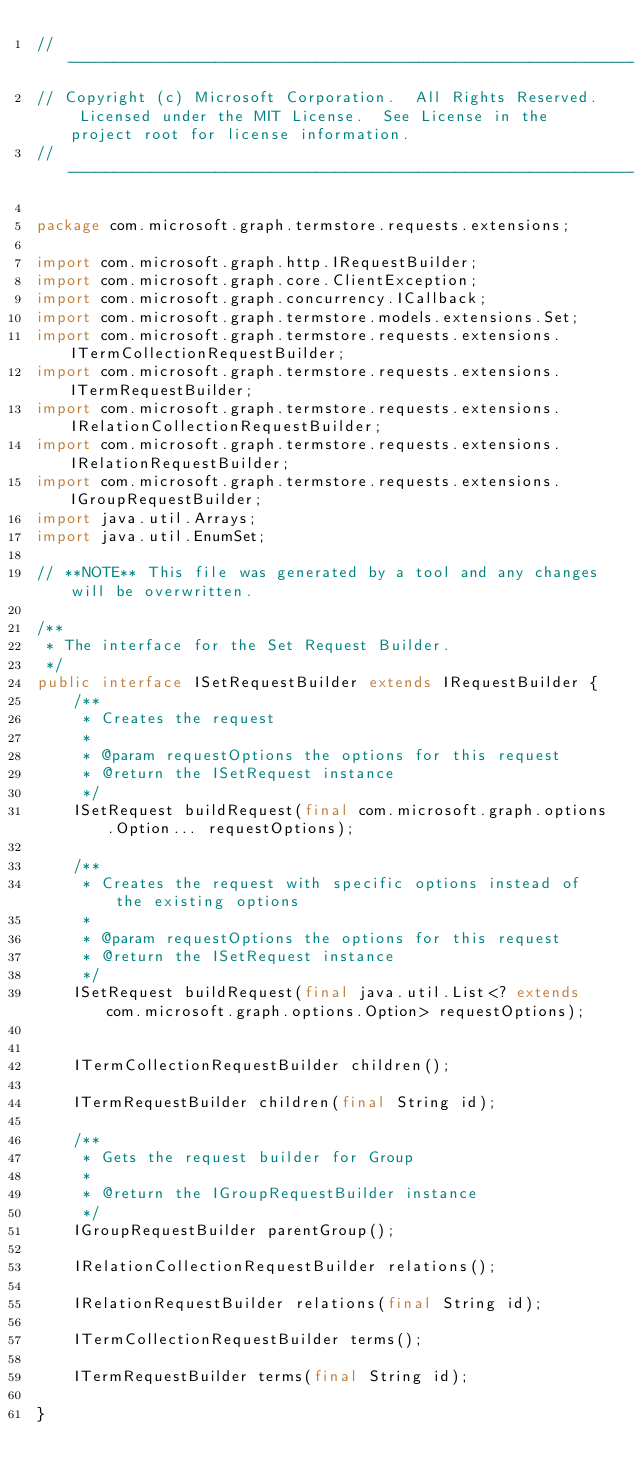Convert code to text. <code><loc_0><loc_0><loc_500><loc_500><_Java_>// ------------------------------------------------------------------------------
// Copyright (c) Microsoft Corporation.  All Rights Reserved.  Licensed under the MIT License.  See License in the project root for license information.
// ------------------------------------------------------------------------------

package com.microsoft.graph.termstore.requests.extensions;

import com.microsoft.graph.http.IRequestBuilder;
import com.microsoft.graph.core.ClientException;
import com.microsoft.graph.concurrency.ICallback;
import com.microsoft.graph.termstore.models.extensions.Set;
import com.microsoft.graph.termstore.requests.extensions.ITermCollectionRequestBuilder;
import com.microsoft.graph.termstore.requests.extensions.ITermRequestBuilder;
import com.microsoft.graph.termstore.requests.extensions.IRelationCollectionRequestBuilder;
import com.microsoft.graph.termstore.requests.extensions.IRelationRequestBuilder;
import com.microsoft.graph.termstore.requests.extensions.IGroupRequestBuilder;
import java.util.Arrays;
import java.util.EnumSet;

// **NOTE** This file was generated by a tool and any changes will be overwritten.

/**
 * The interface for the Set Request Builder.
 */
public interface ISetRequestBuilder extends IRequestBuilder {
    /**
     * Creates the request
     *
     * @param requestOptions the options for this request
     * @return the ISetRequest instance
     */
    ISetRequest buildRequest(final com.microsoft.graph.options.Option... requestOptions);

    /**
     * Creates the request with specific options instead of the existing options
     *
     * @param requestOptions the options for this request
     * @return the ISetRequest instance
     */
    ISetRequest buildRequest(final java.util.List<? extends com.microsoft.graph.options.Option> requestOptions);


    ITermCollectionRequestBuilder children();

    ITermRequestBuilder children(final String id);

    /**
     * Gets the request builder for Group
     *
     * @return the IGroupRequestBuilder instance
     */
    IGroupRequestBuilder parentGroup();

    IRelationCollectionRequestBuilder relations();

    IRelationRequestBuilder relations(final String id);

    ITermCollectionRequestBuilder terms();

    ITermRequestBuilder terms(final String id);

}</code> 